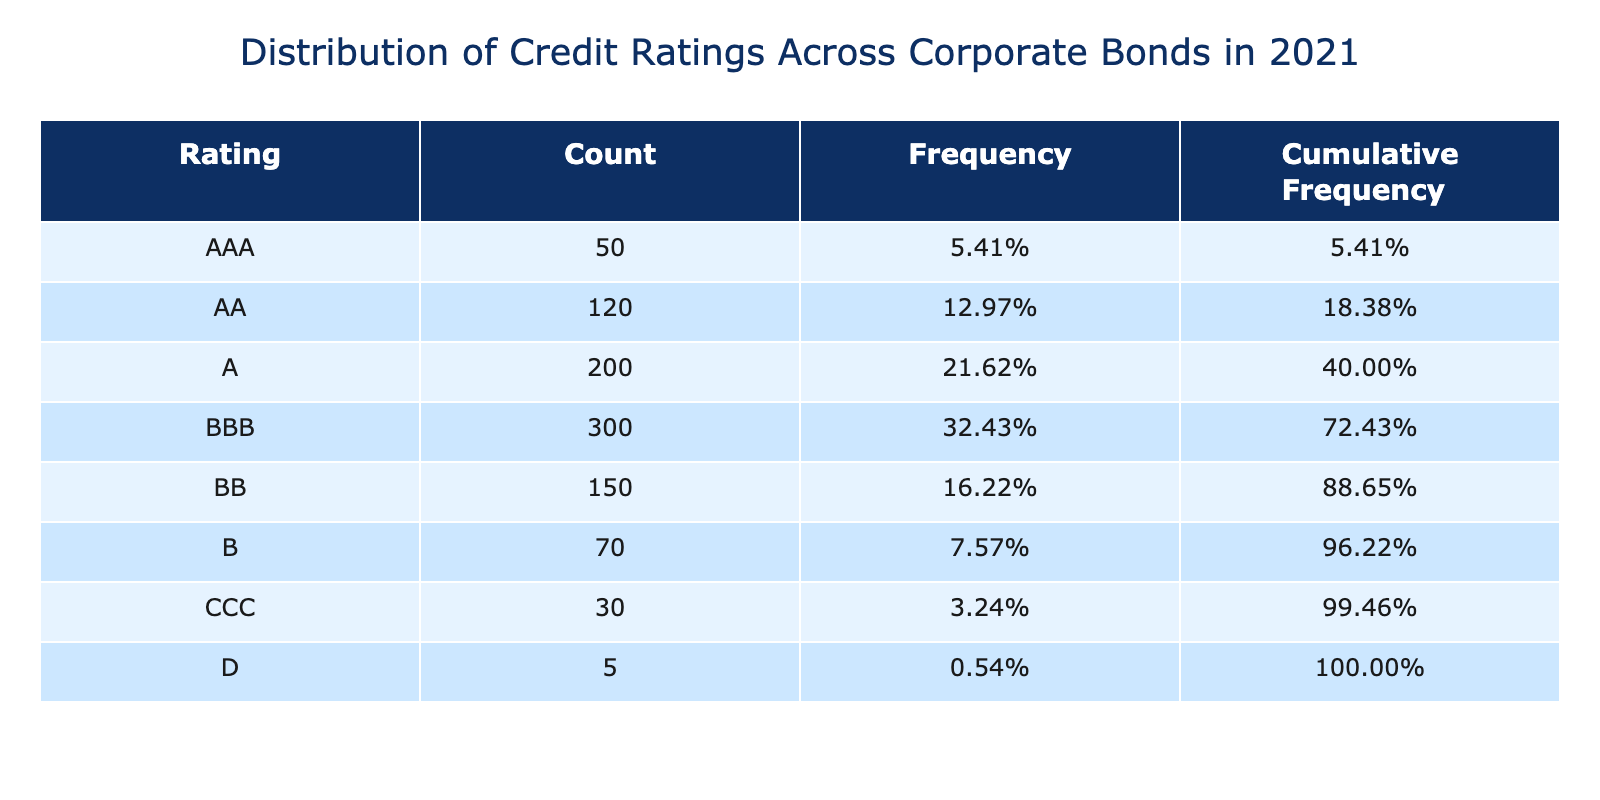What percentage of corporate bonds were rated AAA? From the table, the Count for AAA is 50. The total number of bonds is the sum of all counts: 50 + 120 + 200 + 300 + 150 + 70 + 30 + 5 = 1025. To find the percentage, divide the count for AAA by the total: (50 / 1025) * 100 = 4.88%.
Answer: 4.88% How many bonds were rated B or lower? The ratings B, CCC, and D have the following counts: B = 70, CCC = 30, D = 5. Adding these gives: 70 + 30 + 5 = 105.
Answer: 105 Which rating had the highest frequency? The highest count is for the rating BBB, which has a count of 300. To confirm it has the highest frequency, we can compare it with the others: 50 (AAA), 120 (AA), 200 (A), 300 (BBB), 150 (BB), 70 (B), 30 (CCC), 5 (D). BBB is indeed the highest.
Answer: BBB Is the count of bonds rated AAA greater than the combined total of those rated B and below? The combined count of B and below is 70 (B) + 30 (CCC) + 5 (D) = 105. The count for AAA is 50. Since 50 is not greater than 105, the answer is no.
Answer: No What is the cumulative frequency for the BB rating? The Count for BB is 150. First, we find the frequency for each rating. BB's frequency is (150 / 1025) * 100 = 14.63%. Next, we sum frequencies for AAA, AA, A, BBB, and BB. Thus, cumulative frequency for BB = 4.88% + 11.71% + 19.51% + 29.27% + 14.63% = 80%.
Answer: 80% How does the number of bonds rated A compare to those rated AA? The count of bonds rated A is 200, and for AA it is 120. We can see that 200 is greater than 120.
Answer: A is greater than AA What is the total percentage of bonds rated BBB or better? The ratings and counts are: AAA (50), AA (120), A (200), BBB (300). Adding these gives: 50 + 120 + 200 + 300 = 670. The total number of bonds is still 1025. So, the percentage is (670 / 1025) * 100 = 65.12%.
Answer: 65.12% Is the number of bonds rated CCC fewer than those rated BBB? The count for CCC is 30 while the count for BBB is 300. Since 30 is less than 300, the answer is yes.
Answer: Yes What is the cumulative frequency percentage for all ratings below BB? We need to sum frequencies for AAA (4.88%), AA (11.71%), A (19.51%), BBB (29.27%), BB (14.63%), and then find the cumulative frequency for all ratings below BB. However, BB's contributions will not be included. Thus, cumulative = 4.88% + 11.71% + 19.51% + 29.27% = 65.37%.
Answer: 65.37% 